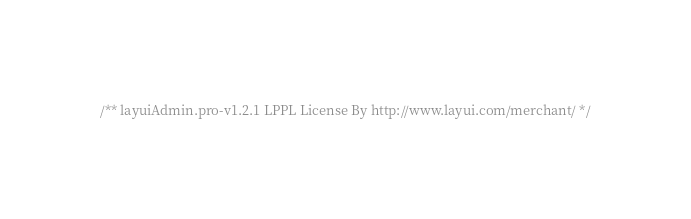Convert code to text. <code><loc_0><loc_0><loc_500><loc_500><_CSS_>/** layuiAdmin.pro-v1.2.1 LPPL License By http://www.layui.com/merchant/ */</code> 